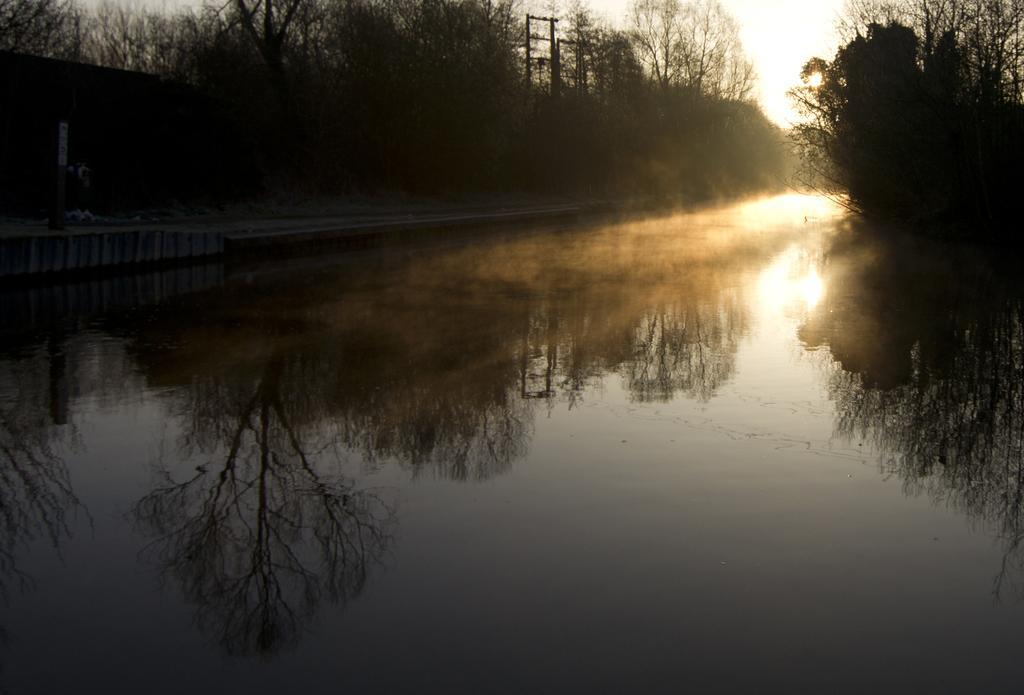How would you summarize this image in a sentence or two? This picture shows water and few trees and we see electrical poles and a cloudy sky with sunlight. 